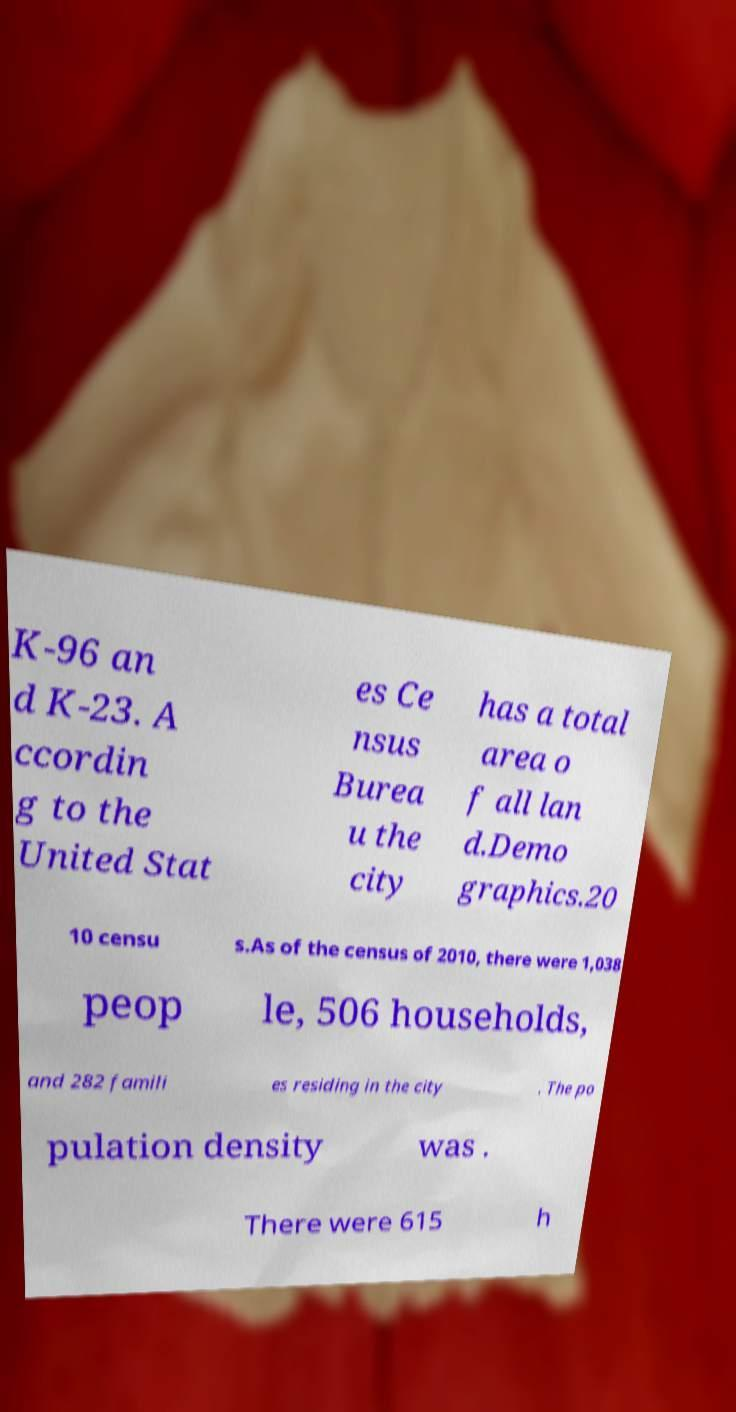Please read and relay the text visible in this image. What does it say? K-96 an d K-23. A ccordin g to the United Stat es Ce nsus Burea u the city has a total area o f all lan d.Demo graphics.20 10 censu s.As of the census of 2010, there were 1,038 peop le, 506 households, and 282 famili es residing in the city . The po pulation density was . There were 615 h 